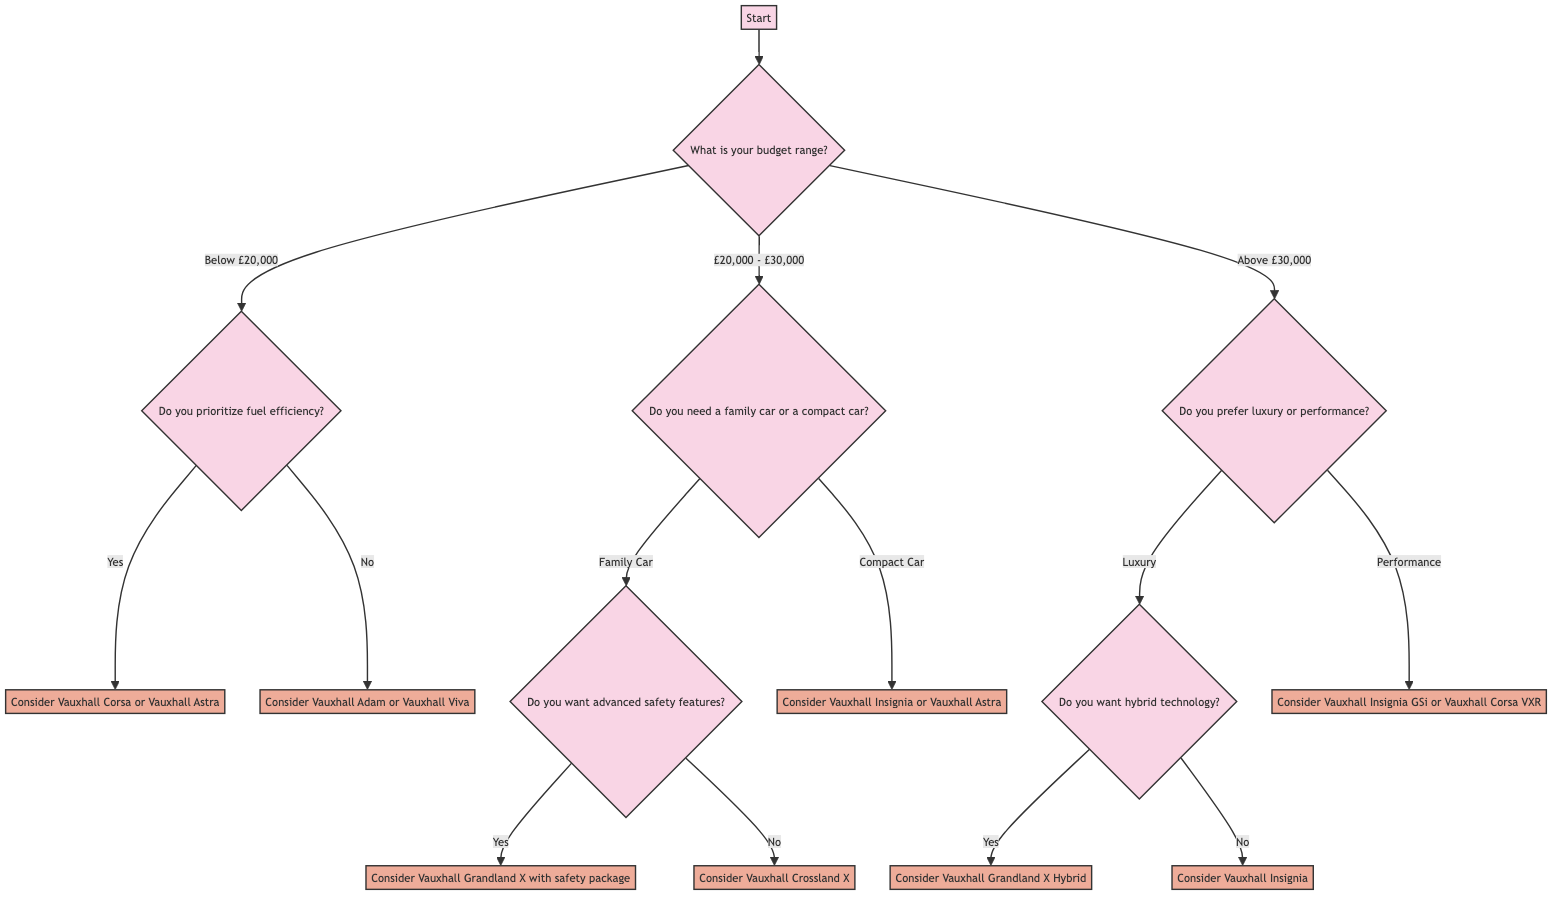What is the first question in the diagram? The first question is asked at the root node and reads, "What is your budget range?" which guides the user on their financial constraints before making a car purchase decision.
Answer: What is your budget range? How many car options are available for a budget below £20,000? In this budget range, there are two distinct options based on fuel efficiency. If the user prioritizes fuel efficiency, they are directed to consider the Vauxhall Corsa or Vauxhall Astra; if not, they are directed to consider the Vauxhall Adam or Vauxhall Viva. Thus, there are a total of two options.
Answer: 2 What is the action if the budget is above £30,000 and the preference is luxury? Following the decision path, if the budget is above £30,000 and luxury is preferred, the next question asks about the desire for hybrid technology. Depending on that answer, a specific Vauxhall model will be suggested. The final action, if hybrid technology is desired, is to "Consider Vauxhall Grandland X Hybrid."
Answer: Consider Vauxhall Grandland X Hybrid What car models should be considered if the user needs a family car and does not want advanced safety features? In this scenario, the user first indicates they need a family car, which branches into a question about advanced safety features. If the user answers "No" to wanting advanced safety features, they will be directed to consider the Vauxhall Crossland X as their vehicle option.
Answer: Consider Vauxhall Crossland X What are the two options when the budget is £20,000 to £30,000? In this budget range, the user is prompted to specify whether they need a family car or a compact car. Based on their response, the next actions differ: a family car leads to further questioning regarding safety features, while a compact car leads directly to considering the Vauxhall Insignia or Vauxhall Astra. Hence, the two options are family car or compact car.
Answer: Family Car or Compact Car 